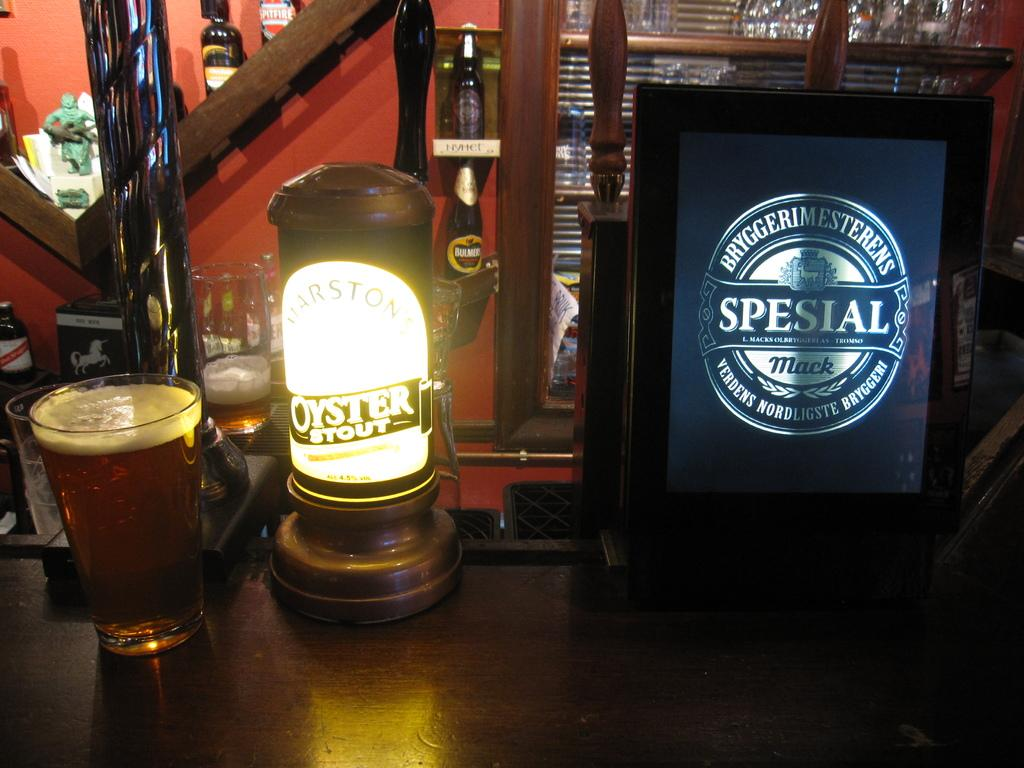<image>
Relay a brief, clear account of the picture shown. A bar with a glass of beer next to something that says Oyster Stout. 